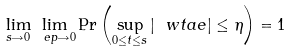Convert formula to latex. <formula><loc_0><loc_0><loc_500><loc_500>\lim _ { s \rightarrow 0 } \lim _ { \ e p \rightarrow 0 } \Pr \left ( \sup _ { 0 \leq t \leq s } | \ w t a e | \leq \eta \right ) = 1</formula> 